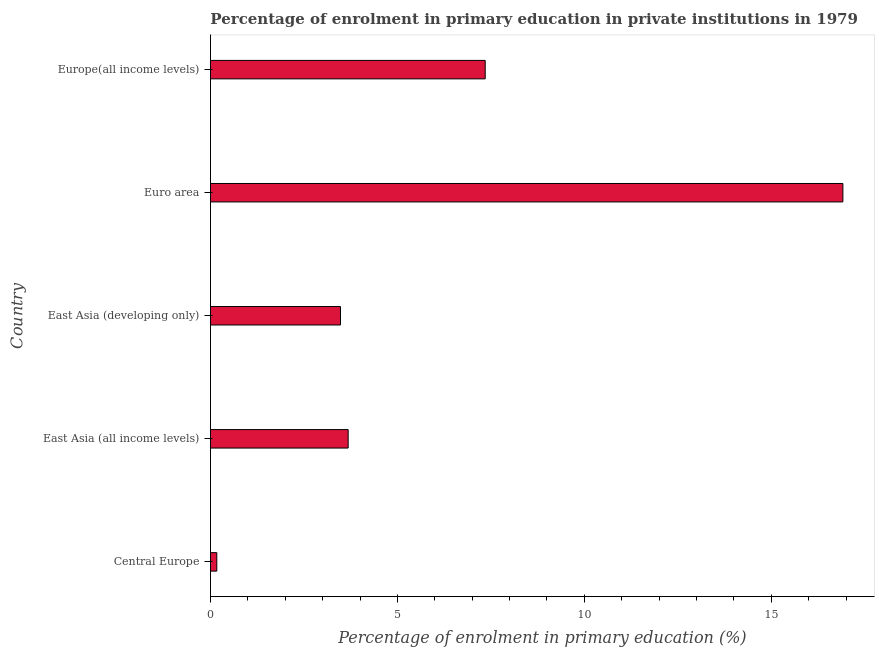Does the graph contain grids?
Make the answer very short. No. What is the title of the graph?
Your response must be concise. Percentage of enrolment in primary education in private institutions in 1979. What is the label or title of the X-axis?
Provide a short and direct response. Percentage of enrolment in primary education (%). What is the enrolment percentage in primary education in East Asia (developing only)?
Ensure brevity in your answer.  3.48. Across all countries, what is the maximum enrolment percentage in primary education?
Your answer should be very brief. 16.91. Across all countries, what is the minimum enrolment percentage in primary education?
Give a very brief answer. 0.17. In which country was the enrolment percentage in primary education minimum?
Keep it short and to the point. Central Europe. What is the sum of the enrolment percentage in primary education?
Provide a short and direct response. 31.59. What is the difference between the enrolment percentage in primary education in Central Europe and Europe(all income levels)?
Make the answer very short. -7.18. What is the average enrolment percentage in primary education per country?
Make the answer very short. 6.32. What is the median enrolment percentage in primary education?
Ensure brevity in your answer.  3.68. In how many countries, is the enrolment percentage in primary education greater than 7 %?
Offer a very short reply. 2. What is the ratio of the enrolment percentage in primary education in Central Europe to that in East Asia (developing only)?
Provide a succinct answer. 0.05. Is the enrolment percentage in primary education in Central Europe less than that in Europe(all income levels)?
Give a very brief answer. Yes. What is the difference between the highest and the second highest enrolment percentage in primary education?
Your answer should be compact. 9.57. Is the sum of the enrolment percentage in primary education in East Asia (developing only) and Euro area greater than the maximum enrolment percentage in primary education across all countries?
Offer a terse response. Yes. What is the difference between the highest and the lowest enrolment percentage in primary education?
Your answer should be very brief. 16.75. In how many countries, is the enrolment percentage in primary education greater than the average enrolment percentage in primary education taken over all countries?
Offer a terse response. 2. How many bars are there?
Your answer should be very brief. 5. How many countries are there in the graph?
Offer a terse response. 5. What is the Percentage of enrolment in primary education (%) of Central Europe?
Ensure brevity in your answer.  0.17. What is the Percentage of enrolment in primary education (%) of East Asia (all income levels)?
Your response must be concise. 3.68. What is the Percentage of enrolment in primary education (%) of East Asia (developing only)?
Your answer should be very brief. 3.48. What is the Percentage of enrolment in primary education (%) in Euro area?
Ensure brevity in your answer.  16.91. What is the Percentage of enrolment in primary education (%) of Europe(all income levels)?
Ensure brevity in your answer.  7.35. What is the difference between the Percentage of enrolment in primary education (%) in Central Europe and East Asia (all income levels)?
Provide a succinct answer. -3.51. What is the difference between the Percentage of enrolment in primary education (%) in Central Europe and East Asia (developing only)?
Offer a terse response. -3.31. What is the difference between the Percentage of enrolment in primary education (%) in Central Europe and Euro area?
Your answer should be very brief. -16.75. What is the difference between the Percentage of enrolment in primary education (%) in Central Europe and Europe(all income levels)?
Your response must be concise. -7.18. What is the difference between the Percentage of enrolment in primary education (%) in East Asia (all income levels) and East Asia (developing only)?
Your answer should be compact. 0.21. What is the difference between the Percentage of enrolment in primary education (%) in East Asia (all income levels) and Euro area?
Provide a short and direct response. -13.23. What is the difference between the Percentage of enrolment in primary education (%) in East Asia (all income levels) and Europe(all income levels)?
Offer a terse response. -3.67. What is the difference between the Percentage of enrolment in primary education (%) in East Asia (developing only) and Euro area?
Your answer should be very brief. -13.44. What is the difference between the Percentage of enrolment in primary education (%) in East Asia (developing only) and Europe(all income levels)?
Keep it short and to the point. -3.87. What is the difference between the Percentage of enrolment in primary education (%) in Euro area and Europe(all income levels)?
Your answer should be very brief. 9.57. What is the ratio of the Percentage of enrolment in primary education (%) in Central Europe to that in East Asia (all income levels)?
Ensure brevity in your answer.  0.05. What is the ratio of the Percentage of enrolment in primary education (%) in Central Europe to that in East Asia (developing only)?
Your answer should be very brief. 0.05. What is the ratio of the Percentage of enrolment in primary education (%) in Central Europe to that in Euro area?
Your answer should be compact. 0.01. What is the ratio of the Percentage of enrolment in primary education (%) in Central Europe to that in Europe(all income levels)?
Offer a terse response. 0.02. What is the ratio of the Percentage of enrolment in primary education (%) in East Asia (all income levels) to that in East Asia (developing only)?
Ensure brevity in your answer.  1.06. What is the ratio of the Percentage of enrolment in primary education (%) in East Asia (all income levels) to that in Euro area?
Provide a short and direct response. 0.22. What is the ratio of the Percentage of enrolment in primary education (%) in East Asia (all income levels) to that in Europe(all income levels)?
Offer a terse response. 0.5. What is the ratio of the Percentage of enrolment in primary education (%) in East Asia (developing only) to that in Euro area?
Ensure brevity in your answer.  0.21. What is the ratio of the Percentage of enrolment in primary education (%) in East Asia (developing only) to that in Europe(all income levels)?
Provide a succinct answer. 0.47. What is the ratio of the Percentage of enrolment in primary education (%) in Euro area to that in Europe(all income levels)?
Offer a terse response. 2.3. 